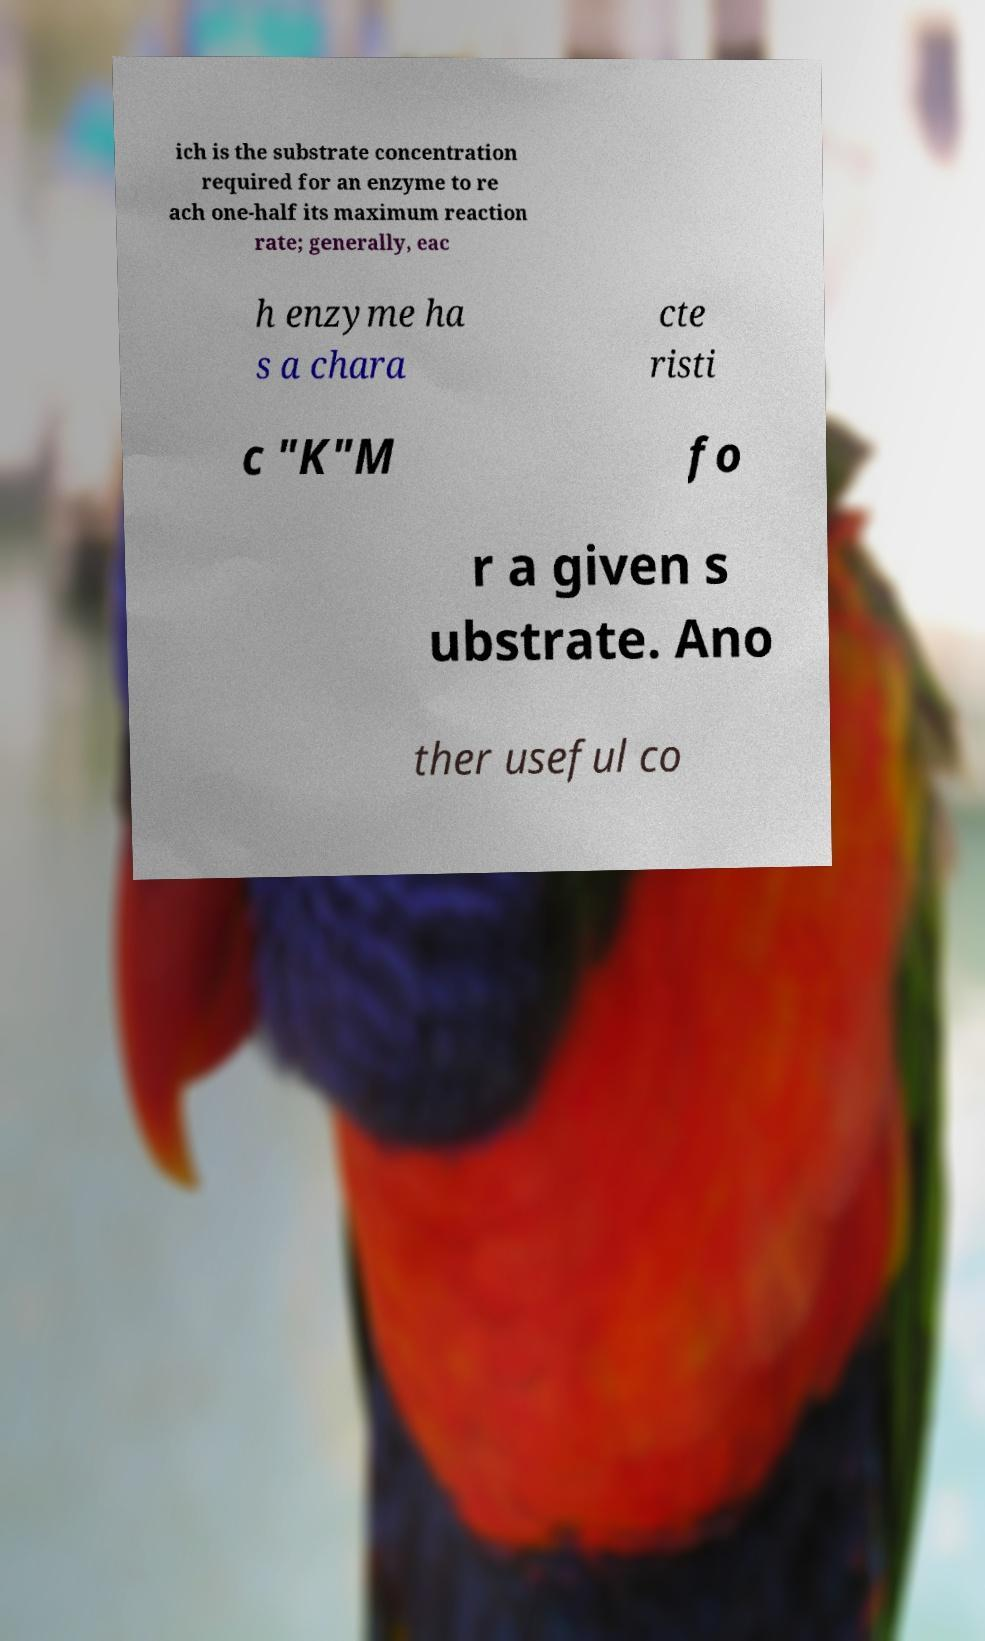Could you extract and type out the text from this image? ich is the substrate concentration required for an enzyme to re ach one-half its maximum reaction rate; generally, eac h enzyme ha s a chara cte risti c "K"M fo r a given s ubstrate. Ano ther useful co 